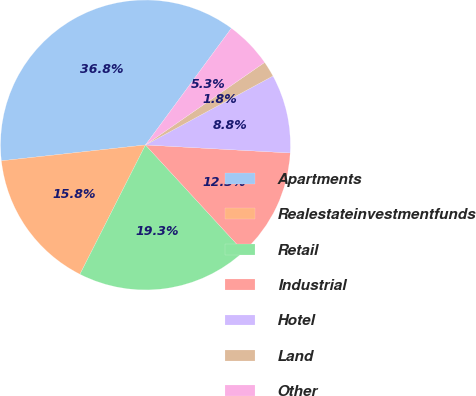Convert chart. <chart><loc_0><loc_0><loc_500><loc_500><pie_chart><fcel>Apartments<fcel>Realestateinvestmentfunds<fcel>Retail<fcel>Industrial<fcel>Hotel<fcel>Land<fcel>Other<nl><fcel>36.84%<fcel>15.79%<fcel>19.3%<fcel>12.28%<fcel>8.77%<fcel>1.75%<fcel>5.26%<nl></chart> 